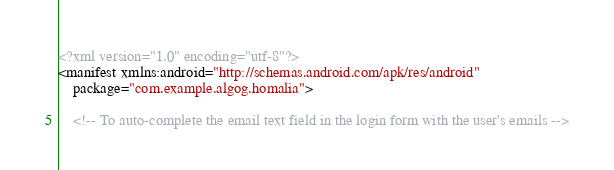<code> <loc_0><loc_0><loc_500><loc_500><_XML_><?xml version="1.0" encoding="utf-8"?>
<manifest xmlns:android="http://schemas.android.com/apk/res/android"
    package="com.example.algog.homalia">

    <!-- To auto-complete the email text field in the login form with the user's emails --></code> 